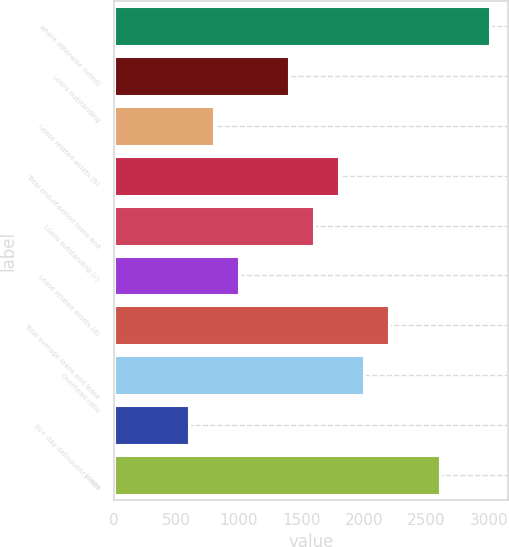Convert chart to OTSL. <chart><loc_0><loc_0><loc_500><loc_500><bar_chart><fcel>where otherwise noted)<fcel>Loans outstanding<fcel>Lease related assets (b)<fcel>Total end-of-period loans and<fcel>Loans outstanding (c)<fcel>Lease related assets (d)<fcel>Total average loans and lease<fcel>Overhead ratio<fcel>30+ day delinquency rate<fcel>Loans<nl><fcel>3007.37<fcel>1403.61<fcel>802.2<fcel>1804.55<fcel>1604.08<fcel>1002.67<fcel>2205.49<fcel>2005.02<fcel>601.73<fcel>2606.43<nl></chart> 